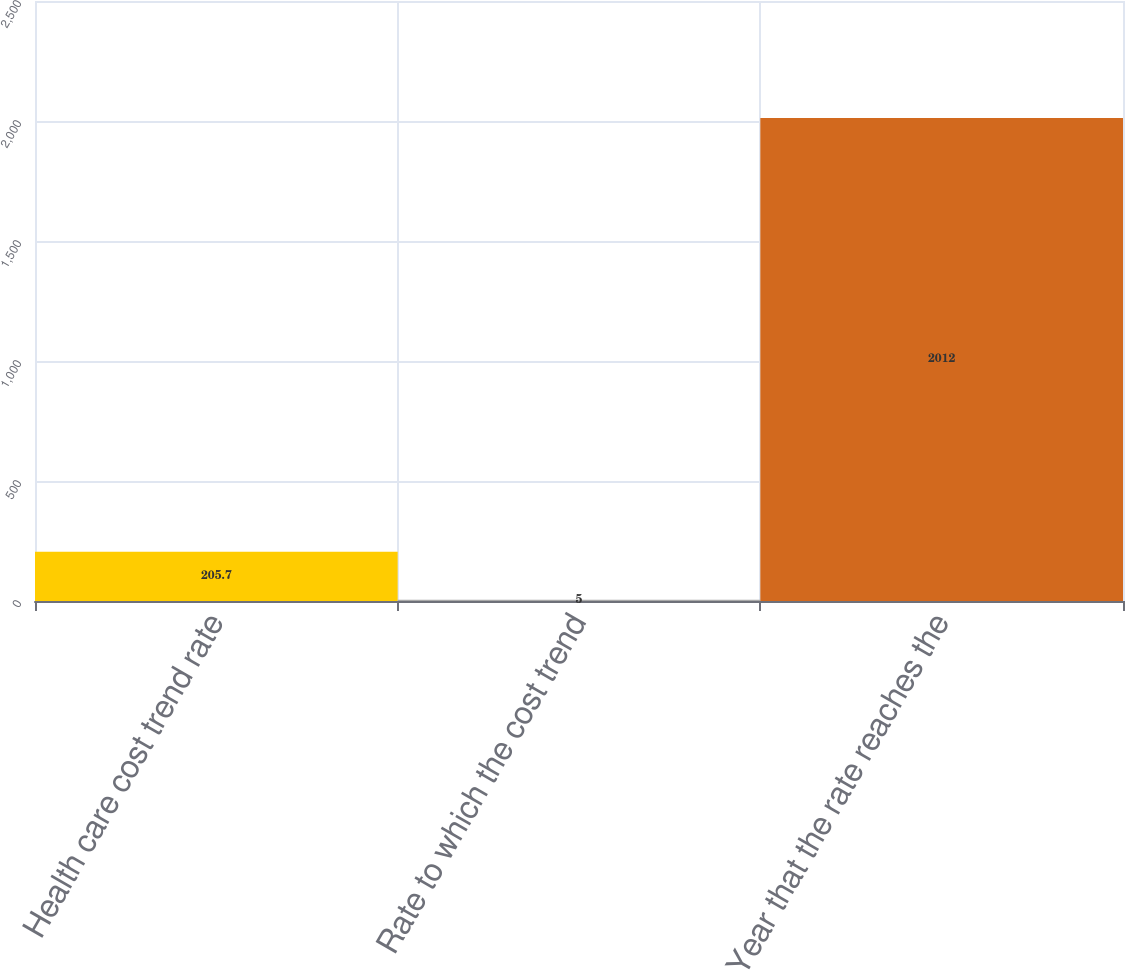<chart> <loc_0><loc_0><loc_500><loc_500><bar_chart><fcel>Health care cost trend rate<fcel>Rate to which the cost trend<fcel>Year that the rate reaches the<nl><fcel>205.7<fcel>5<fcel>2012<nl></chart> 